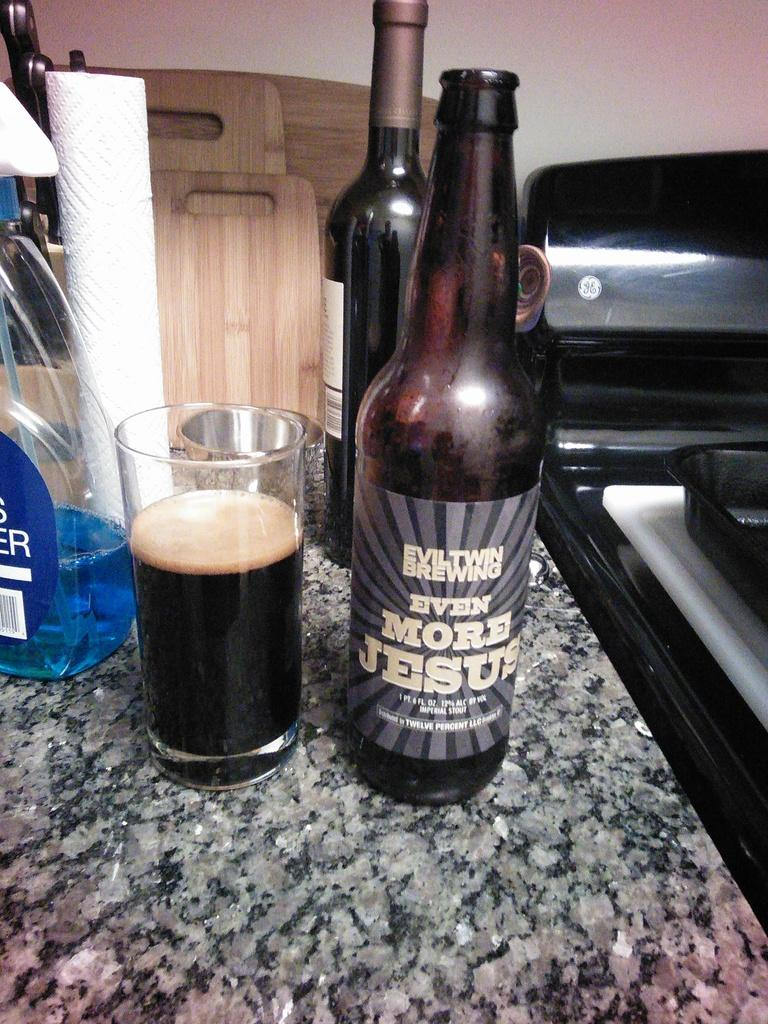<image>
Render a clear and concise summary of the photo. A two thirds filled glass next to a bottle of Even 